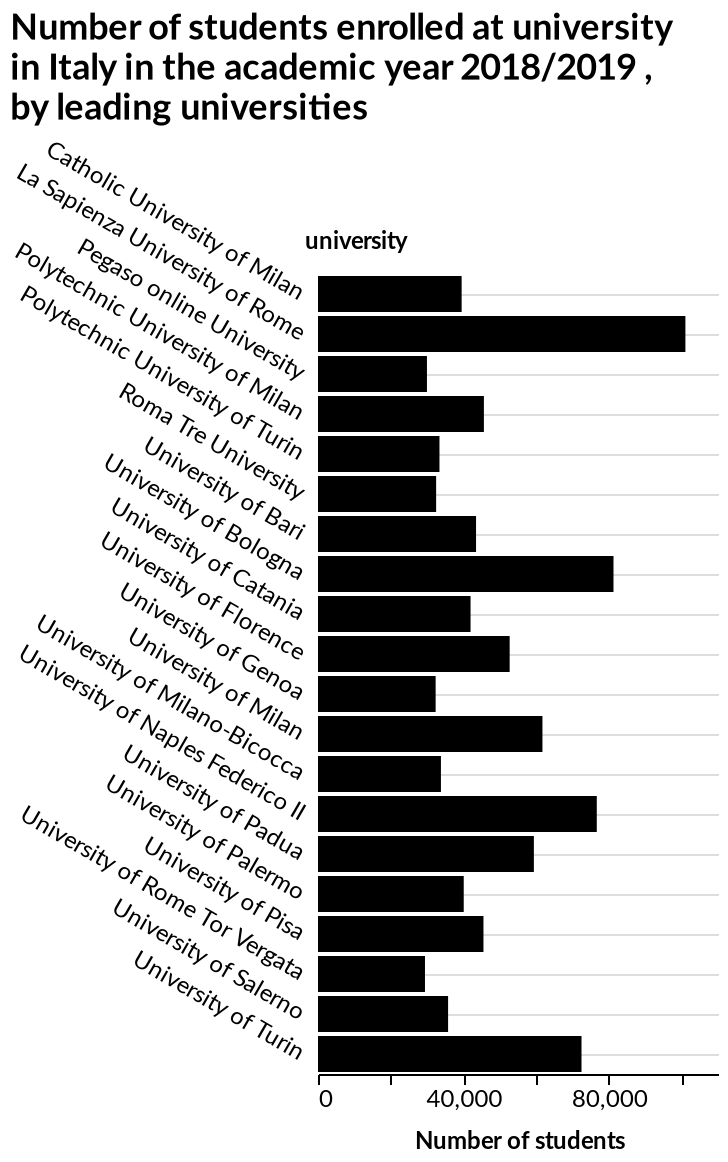<image>
please describe the details of the chart This bar chart is labeled Number of students enrolled at university in Italy in the academic year 2018/2019 , by leading universities. On the x-axis, Number of students is measured. university is measured on the y-axis. What is the range of average number of students enrolled at all the universities? The range is between 30,000 and 50,000 students. What does the y-axis represent in the bar chart?  The y-axis represents the leading universities in Italy. Is university measured on the x-axis? No.This bar chart is labeled Number of students enrolled at university in Italy in the academic year 2018/2019 , by leading universities. On the x-axis, Number of students is measured. university is measured on the y-axis. 